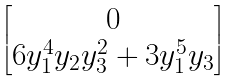Convert formula to latex. <formula><loc_0><loc_0><loc_500><loc_500>\begin{bmatrix} 0 \\ 6 y _ { 1 } ^ { 4 } y _ { 2 } y _ { 3 } ^ { 2 } + 3 y _ { 1 } ^ { 5 } y _ { 3 } \end{bmatrix}</formula> 